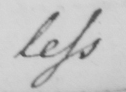What does this handwritten line say? less 